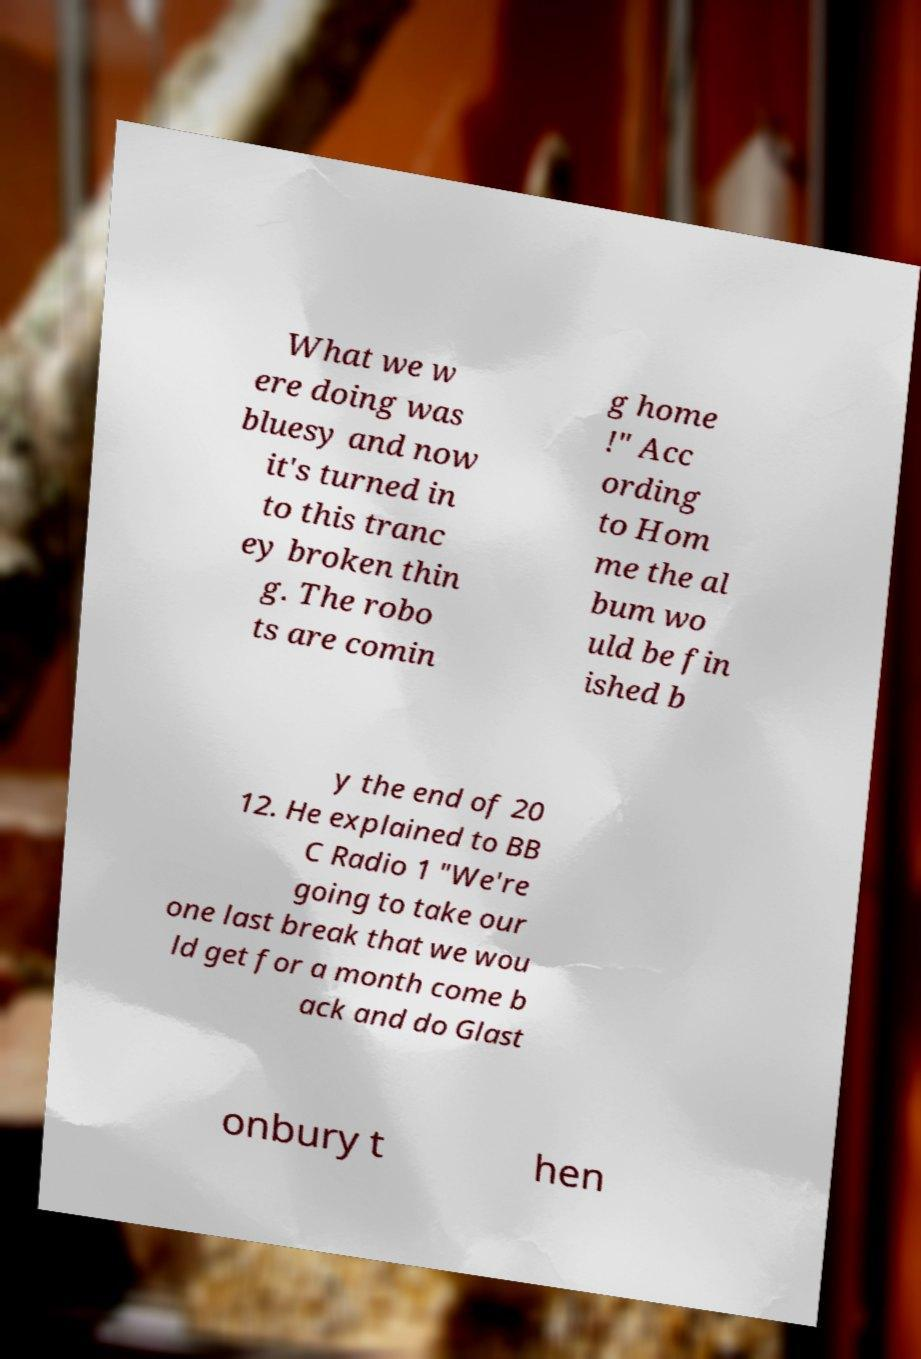I need the written content from this picture converted into text. Can you do that? What we w ere doing was bluesy and now it's turned in to this tranc ey broken thin g. The robo ts are comin g home !" Acc ording to Hom me the al bum wo uld be fin ished b y the end of 20 12. He explained to BB C Radio 1 "We're going to take our one last break that we wou ld get for a month come b ack and do Glast onbury t hen 